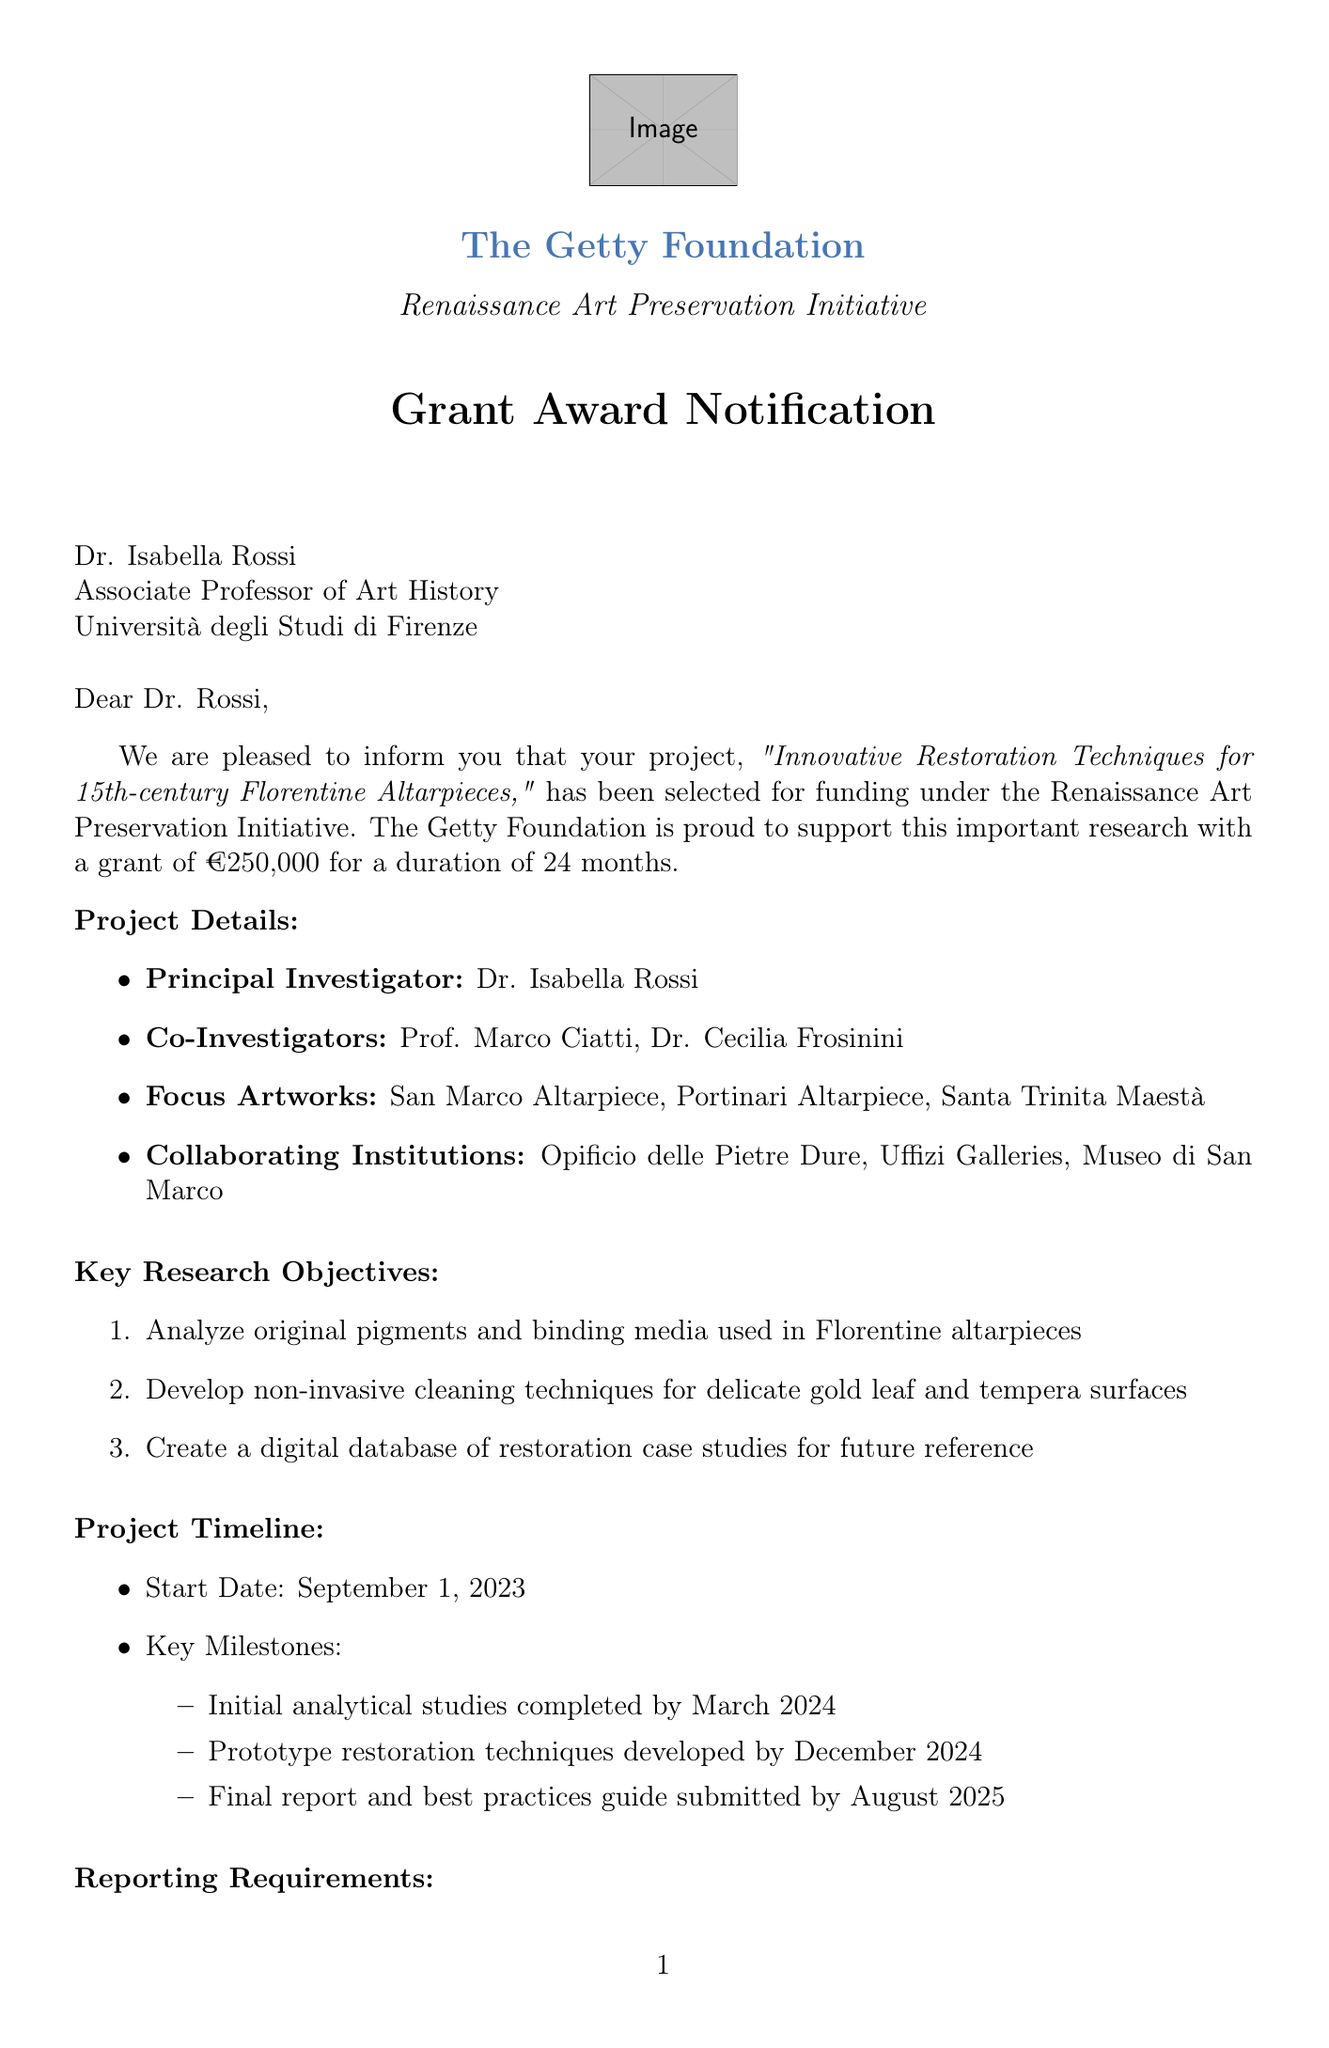What is the award amount? The award amount is explicitly stated in the document, which indicates the funding provided for the project.
Answer: €250,000 Who is the principal investigator? The document mentions the principal investigator directly, identifying the person leading the research team.
Answer: Dr. Isabella Rossi What are the key research objectives? The document lists specific objectives that the project aims to achieve, which highlight its goals.
Answer: Analyze original pigments and binding media used in Florentine altarpieces Which institutions are collaborating on the project? The document outlines the institutions that will work together on the research project, indicating a collaborative effort.
Answer: Opificio delle Pietre Dure, Uffizi Galleries, Museo di San Marco When does the project start? The document specifies the start date of the project, providing a timeline for the research activities.
Answer: September 1, 2023 What is the duration of the project? The document indicates the length of time allocated for the research project, which is important for planning and execution.
Answer: 24 months What is required for financial reporting? The document specifies the type of financial reporting that is expected during the project, which is crucial for accountability.
Answer: Semi-annually What is one expected outcome of the project? The document lists anticipated results from the research, which indicate its impact and contribution to the field.
Answer: Publication of findings in the Journal of the American Institute for Conservation 